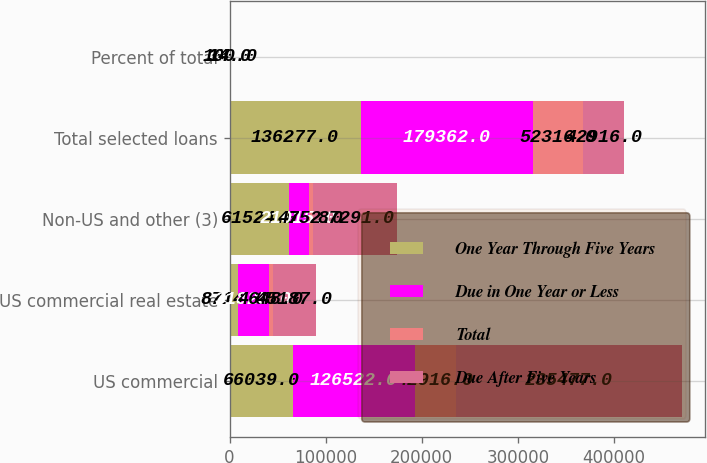<chart> <loc_0><loc_0><loc_500><loc_500><stacked_bar_chart><ecel><fcel>US commercial<fcel>US commercial real estate<fcel>Non-US and other (3)<fcel>Total selected loans<fcel>Percent of total<nl><fcel>One Year Through Five Years<fcel>66039<fcel>8714<fcel>61524<fcel>136277<fcel>37<nl><fcel>Due in One Year or Less<fcel>126522<fcel>31825<fcel>21015<fcel>179362<fcel>49<nl><fcel>Total<fcel>42916<fcel>4648<fcel>4752<fcel>52316<fcel>14<nl><fcel>Due After Five Years<fcel>235477<fcel>45187<fcel>87291<fcel>42916<fcel>100<nl></chart> 